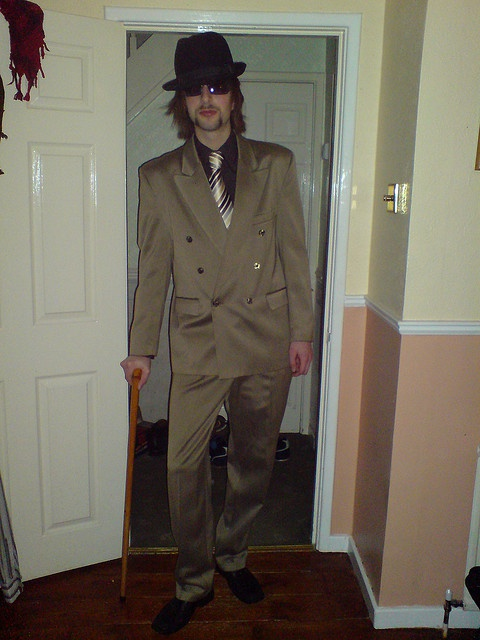Describe the objects in this image and their specific colors. I can see people in black and gray tones and tie in black, gray, darkgray, and tan tones in this image. 